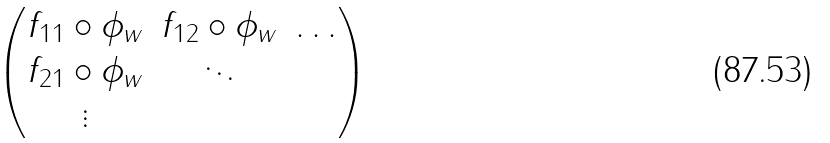<formula> <loc_0><loc_0><loc_500><loc_500>\begin{pmatrix} f _ { 1 1 } \circ \phi _ { w } & f _ { 1 2 } \circ \phi _ { w } & \dots \\ f _ { 2 1 } \circ \phi _ { w } & \ddots \\ \vdots \end{pmatrix}</formula> 